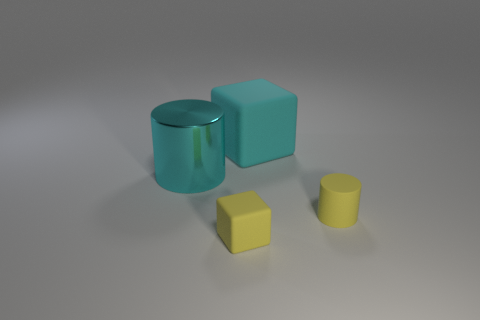Add 1 large cyan metallic cylinders. How many objects exist? 5 Subtract 0 brown balls. How many objects are left? 4 Subtract all big objects. Subtract all tiny yellow matte cylinders. How many objects are left? 1 Add 3 big matte cubes. How many big matte cubes are left? 4 Add 4 tiny cyan spheres. How many tiny cyan spheres exist? 4 